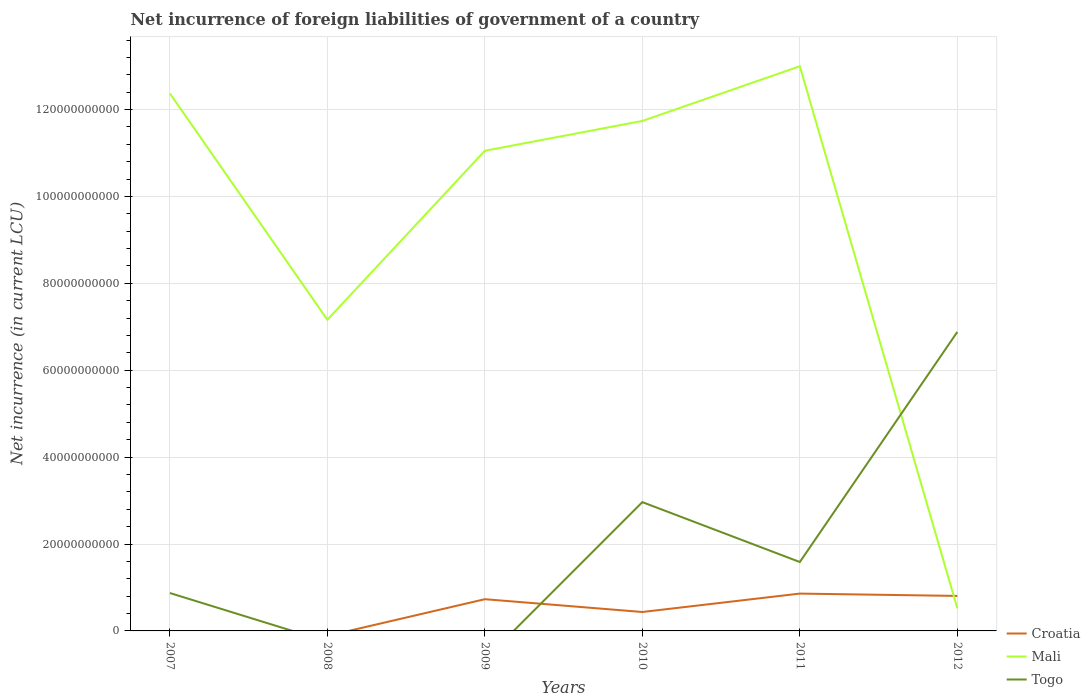Is the number of lines equal to the number of legend labels?
Give a very brief answer. No. Across all years, what is the maximum net incurrence of foreign liabilities in Mali?
Keep it short and to the point. 5.20e+09. What is the total net incurrence of foreign liabilities in Togo in the graph?
Offer a very short reply. -3.92e+1. What is the difference between the highest and the second highest net incurrence of foreign liabilities in Croatia?
Provide a short and direct response. 8.59e+09. Are the values on the major ticks of Y-axis written in scientific E-notation?
Ensure brevity in your answer.  No. Does the graph contain grids?
Your response must be concise. Yes. How are the legend labels stacked?
Provide a short and direct response. Vertical. What is the title of the graph?
Your response must be concise. Net incurrence of foreign liabilities of government of a country. What is the label or title of the X-axis?
Provide a short and direct response. Years. What is the label or title of the Y-axis?
Make the answer very short. Net incurrence (in current LCU). What is the Net incurrence (in current LCU) of Croatia in 2007?
Provide a short and direct response. 0. What is the Net incurrence (in current LCU) in Mali in 2007?
Make the answer very short. 1.24e+11. What is the Net incurrence (in current LCU) of Togo in 2007?
Keep it short and to the point. 8.72e+09. What is the Net incurrence (in current LCU) in Mali in 2008?
Your response must be concise. 7.16e+1. What is the Net incurrence (in current LCU) of Croatia in 2009?
Provide a short and direct response. 7.30e+09. What is the Net incurrence (in current LCU) in Mali in 2009?
Provide a succinct answer. 1.11e+11. What is the Net incurrence (in current LCU) of Croatia in 2010?
Give a very brief answer. 4.36e+09. What is the Net incurrence (in current LCU) of Mali in 2010?
Offer a very short reply. 1.17e+11. What is the Net incurrence (in current LCU) of Togo in 2010?
Keep it short and to the point. 2.96e+1. What is the Net incurrence (in current LCU) in Croatia in 2011?
Your answer should be compact. 8.59e+09. What is the Net incurrence (in current LCU) in Mali in 2011?
Keep it short and to the point. 1.30e+11. What is the Net incurrence (in current LCU) in Togo in 2011?
Keep it short and to the point. 1.59e+1. What is the Net incurrence (in current LCU) in Croatia in 2012?
Keep it short and to the point. 8.06e+09. What is the Net incurrence (in current LCU) of Mali in 2012?
Give a very brief answer. 5.20e+09. What is the Net incurrence (in current LCU) in Togo in 2012?
Ensure brevity in your answer.  6.88e+1. Across all years, what is the maximum Net incurrence (in current LCU) in Croatia?
Your response must be concise. 8.59e+09. Across all years, what is the maximum Net incurrence (in current LCU) of Mali?
Ensure brevity in your answer.  1.30e+11. Across all years, what is the maximum Net incurrence (in current LCU) of Togo?
Make the answer very short. 6.88e+1. Across all years, what is the minimum Net incurrence (in current LCU) of Mali?
Your answer should be compact. 5.20e+09. Across all years, what is the minimum Net incurrence (in current LCU) in Togo?
Give a very brief answer. 0. What is the total Net incurrence (in current LCU) in Croatia in the graph?
Your response must be concise. 2.83e+1. What is the total Net incurrence (in current LCU) in Mali in the graph?
Give a very brief answer. 5.58e+11. What is the total Net incurrence (in current LCU) of Togo in the graph?
Your answer should be compact. 1.23e+11. What is the difference between the Net incurrence (in current LCU) of Mali in 2007 and that in 2008?
Provide a succinct answer. 5.21e+1. What is the difference between the Net incurrence (in current LCU) of Mali in 2007 and that in 2009?
Offer a very short reply. 1.32e+1. What is the difference between the Net incurrence (in current LCU) in Mali in 2007 and that in 2010?
Keep it short and to the point. 6.32e+09. What is the difference between the Net incurrence (in current LCU) of Togo in 2007 and that in 2010?
Your answer should be compact. -2.09e+1. What is the difference between the Net incurrence (in current LCU) of Mali in 2007 and that in 2011?
Keep it short and to the point. -6.27e+09. What is the difference between the Net incurrence (in current LCU) of Togo in 2007 and that in 2011?
Your answer should be very brief. -7.14e+09. What is the difference between the Net incurrence (in current LCU) in Mali in 2007 and that in 2012?
Offer a terse response. 1.18e+11. What is the difference between the Net incurrence (in current LCU) in Togo in 2007 and that in 2012?
Your answer should be very brief. -6.01e+1. What is the difference between the Net incurrence (in current LCU) of Mali in 2008 and that in 2009?
Your answer should be compact. -3.89e+1. What is the difference between the Net incurrence (in current LCU) in Mali in 2008 and that in 2010?
Provide a succinct answer. -4.58e+1. What is the difference between the Net incurrence (in current LCU) in Mali in 2008 and that in 2011?
Offer a terse response. -5.84e+1. What is the difference between the Net incurrence (in current LCU) in Mali in 2008 and that in 2012?
Keep it short and to the point. 6.64e+1. What is the difference between the Net incurrence (in current LCU) of Croatia in 2009 and that in 2010?
Provide a short and direct response. 2.95e+09. What is the difference between the Net incurrence (in current LCU) of Mali in 2009 and that in 2010?
Your answer should be compact. -6.86e+09. What is the difference between the Net incurrence (in current LCU) of Croatia in 2009 and that in 2011?
Your answer should be compact. -1.29e+09. What is the difference between the Net incurrence (in current LCU) in Mali in 2009 and that in 2011?
Your response must be concise. -1.94e+1. What is the difference between the Net incurrence (in current LCU) of Croatia in 2009 and that in 2012?
Provide a short and direct response. -7.54e+08. What is the difference between the Net incurrence (in current LCU) in Mali in 2009 and that in 2012?
Offer a very short reply. 1.05e+11. What is the difference between the Net incurrence (in current LCU) in Croatia in 2010 and that in 2011?
Make the answer very short. -4.24e+09. What is the difference between the Net incurrence (in current LCU) of Mali in 2010 and that in 2011?
Make the answer very short. -1.26e+1. What is the difference between the Net incurrence (in current LCU) in Togo in 2010 and that in 2011?
Offer a terse response. 1.38e+1. What is the difference between the Net incurrence (in current LCU) of Croatia in 2010 and that in 2012?
Provide a short and direct response. -3.70e+09. What is the difference between the Net incurrence (in current LCU) of Mali in 2010 and that in 2012?
Keep it short and to the point. 1.12e+11. What is the difference between the Net incurrence (in current LCU) in Togo in 2010 and that in 2012?
Provide a succinct answer. -3.92e+1. What is the difference between the Net incurrence (in current LCU) in Croatia in 2011 and that in 2012?
Offer a terse response. 5.36e+08. What is the difference between the Net incurrence (in current LCU) of Mali in 2011 and that in 2012?
Your response must be concise. 1.25e+11. What is the difference between the Net incurrence (in current LCU) of Togo in 2011 and that in 2012?
Provide a short and direct response. -5.30e+1. What is the difference between the Net incurrence (in current LCU) in Mali in 2007 and the Net incurrence (in current LCU) in Togo in 2010?
Make the answer very short. 9.41e+1. What is the difference between the Net incurrence (in current LCU) in Mali in 2007 and the Net incurrence (in current LCU) in Togo in 2011?
Your response must be concise. 1.08e+11. What is the difference between the Net incurrence (in current LCU) of Mali in 2007 and the Net incurrence (in current LCU) of Togo in 2012?
Provide a short and direct response. 5.49e+1. What is the difference between the Net incurrence (in current LCU) of Mali in 2008 and the Net incurrence (in current LCU) of Togo in 2010?
Provide a short and direct response. 4.20e+1. What is the difference between the Net incurrence (in current LCU) of Mali in 2008 and the Net incurrence (in current LCU) of Togo in 2011?
Your answer should be very brief. 5.58e+1. What is the difference between the Net incurrence (in current LCU) in Mali in 2008 and the Net incurrence (in current LCU) in Togo in 2012?
Your response must be concise. 2.80e+09. What is the difference between the Net incurrence (in current LCU) of Croatia in 2009 and the Net incurrence (in current LCU) of Mali in 2010?
Your answer should be very brief. -1.10e+11. What is the difference between the Net incurrence (in current LCU) of Croatia in 2009 and the Net incurrence (in current LCU) of Togo in 2010?
Your response must be concise. -2.23e+1. What is the difference between the Net incurrence (in current LCU) of Mali in 2009 and the Net incurrence (in current LCU) of Togo in 2010?
Your answer should be compact. 8.09e+1. What is the difference between the Net incurrence (in current LCU) of Croatia in 2009 and the Net incurrence (in current LCU) of Mali in 2011?
Offer a very short reply. -1.23e+11. What is the difference between the Net incurrence (in current LCU) in Croatia in 2009 and the Net incurrence (in current LCU) in Togo in 2011?
Offer a very short reply. -8.56e+09. What is the difference between the Net incurrence (in current LCU) of Mali in 2009 and the Net incurrence (in current LCU) of Togo in 2011?
Your response must be concise. 9.47e+1. What is the difference between the Net incurrence (in current LCU) in Croatia in 2009 and the Net incurrence (in current LCU) in Mali in 2012?
Provide a succinct answer. 2.10e+09. What is the difference between the Net incurrence (in current LCU) in Croatia in 2009 and the Net incurrence (in current LCU) in Togo in 2012?
Ensure brevity in your answer.  -6.15e+1. What is the difference between the Net incurrence (in current LCU) in Mali in 2009 and the Net incurrence (in current LCU) in Togo in 2012?
Your response must be concise. 4.17e+1. What is the difference between the Net incurrence (in current LCU) in Croatia in 2010 and the Net incurrence (in current LCU) in Mali in 2011?
Offer a terse response. -1.26e+11. What is the difference between the Net incurrence (in current LCU) in Croatia in 2010 and the Net incurrence (in current LCU) in Togo in 2011?
Make the answer very short. -1.15e+1. What is the difference between the Net incurrence (in current LCU) of Mali in 2010 and the Net incurrence (in current LCU) of Togo in 2011?
Keep it short and to the point. 1.02e+11. What is the difference between the Net incurrence (in current LCU) of Croatia in 2010 and the Net incurrence (in current LCU) of Mali in 2012?
Your response must be concise. -8.47e+08. What is the difference between the Net incurrence (in current LCU) in Croatia in 2010 and the Net incurrence (in current LCU) in Togo in 2012?
Provide a short and direct response. -6.45e+1. What is the difference between the Net incurrence (in current LCU) of Mali in 2010 and the Net incurrence (in current LCU) of Togo in 2012?
Make the answer very short. 4.86e+1. What is the difference between the Net incurrence (in current LCU) in Croatia in 2011 and the Net incurrence (in current LCU) in Mali in 2012?
Provide a succinct answer. 3.39e+09. What is the difference between the Net incurrence (in current LCU) in Croatia in 2011 and the Net incurrence (in current LCU) in Togo in 2012?
Provide a succinct answer. -6.02e+1. What is the difference between the Net incurrence (in current LCU) in Mali in 2011 and the Net incurrence (in current LCU) in Togo in 2012?
Provide a succinct answer. 6.11e+1. What is the average Net incurrence (in current LCU) in Croatia per year?
Make the answer very short. 4.72e+09. What is the average Net incurrence (in current LCU) in Mali per year?
Give a very brief answer. 9.31e+1. What is the average Net incurrence (in current LCU) of Togo per year?
Provide a short and direct response. 2.05e+1. In the year 2007, what is the difference between the Net incurrence (in current LCU) of Mali and Net incurrence (in current LCU) of Togo?
Your answer should be compact. 1.15e+11. In the year 2009, what is the difference between the Net incurrence (in current LCU) in Croatia and Net incurrence (in current LCU) in Mali?
Keep it short and to the point. -1.03e+11. In the year 2010, what is the difference between the Net incurrence (in current LCU) in Croatia and Net incurrence (in current LCU) in Mali?
Your response must be concise. -1.13e+11. In the year 2010, what is the difference between the Net incurrence (in current LCU) in Croatia and Net incurrence (in current LCU) in Togo?
Your answer should be compact. -2.53e+1. In the year 2010, what is the difference between the Net incurrence (in current LCU) in Mali and Net incurrence (in current LCU) in Togo?
Keep it short and to the point. 8.77e+1. In the year 2011, what is the difference between the Net incurrence (in current LCU) of Croatia and Net incurrence (in current LCU) of Mali?
Offer a terse response. -1.21e+11. In the year 2011, what is the difference between the Net incurrence (in current LCU) of Croatia and Net incurrence (in current LCU) of Togo?
Offer a terse response. -7.27e+09. In the year 2011, what is the difference between the Net incurrence (in current LCU) in Mali and Net incurrence (in current LCU) in Togo?
Give a very brief answer. 1.14e+11. In the year 2012, what is the difference between the Net incurrence (in current LCU) in Croatia and Net incurrence (in current LCU) in Mali?
Offer a very short reply. 2.85e+09. In the year 2012, what is the difference between the Net incurrence (in current LCU) in Croatia and Net incurrence (in current LCU) in Togo?
Your answer should be compact. -6.08e+1. In the year 2012, what is the difference between the Net incurrence (in current LCU) of Mali and Net incurrence (in current LCU) of Togo?
Your answer should be compact. -6.36e+1. What is the ratio of the Net incurrence (in current LCU) of Mali in 2007 to that in 2008?
Offer a very short reply. 1.73. What is the ratio of the Net incurrence (in current LCU) of Mali in 2007 to that in 2009?
Your response must be concise. 1.12. What is the ratio of the Net incurrence (in current LCU) of Mali in 2007 to that in 2010?
Offer a terse response. 1.05. What is the ratio of the Net incurrence (in current LCU) in Togo in 2007 to that in 2010?
Keep it short and to the point. 0.29. What is the ratio of the Net incurrence (in current LCU) in Mali in 2007 to that in 2011?
Offer a terse response. 0.95. What is the ratio of the Net incurrence (in current LCU) of Togo in 2007 to that in 2011?
Keep it short and to the point. 0.55. What is the ratio of the Net incurrence (in current LCU) in Mali in 2007 to that in 2012?
Ensure brevity in your answer.  23.77. What is the ratio of the Net incurrence (in current LCU) in Togo in 2007 to that in 2012?
Provide a succinct answer. 0.13. What is the ratio of the Net incurrence (in current LCU) of Mali in 2008 to that in 2009?
Offer a terse response. 0.65. What is the ratio of the Net incurrence (in current LCU) of Mali in 2008 to that in 2010?
Provide a succinct answer. 0.61. What is the ratio of the Net incurrence (in current LCU) in Mali in 2008 to that in 2011?
Your response must be concise. 0.55. What is the ratio of the Net incurrence (in current LCU) in Mali in 2008 to that in 2012?
Offer a very short reply. 13.76. What is the ratio of the Net incurrence (in current LCU) of Croatia in 2009 to that in 2010?
Provide a short and direct response. 1.68. What is the ratio of the Net incurrence (in current LCU) in Mali in 2009 to that in 2010?
Offer a very short reply. 0.94. What is the ratio of the Net incurrence (in current LCU) in Croatia in 2009 to that in 2011?
Keep it short and to the point. 0.85. What is the ratio of the Net incurrence (in current LCU) of Mali in 2009 to that in 2011?
Make the answer very short. 0.85. What is the ratio of the Net incurrence (in current LCU) of Croatia in 2009 to that in 2012?
Provide a short and direct response. 0.91. What is the ratio of the Net incurrence (in current LCU) in Mali in 2009 to that in 2012?
Provide a succinct answer. 21.24. What is the ratio of the Net incurrence (in current LCU) of Croatia in 2010 to that in 2011?
Keep it short and to the point. 0.51. What is the ratio of the Net incurrence (in current LCU) of Mali in 2010 to that in 2011?
Give a very brief answer. 0.9. What is the ratio of the Net incurrence (in current LCU) in Togo in 2010 to that in 2011?
Your answer should be compact. 1.87. What is the ratio of the Net incurrence (in current LCU) of Croatia in 2010 to that in 2012?
Your response must be concise. 0.54. What is the ratio of the Net incurrence (in current LCU) of Mali in 2010 to that in 2012?
Offer a terse response. 22.56. What is the ratio of the Net incurrence (in current LCU) of Togo in 2010 to that in 2012?
Make the answer very short. 0.43. What is the ratio of the Net incurrence (in current LCU) of Croatia in 2011 to that in 2012?
Offer a terse response. 1.07. What is the ratio of the Net incurrence (in current LCU) of Mali in 2011 to that in 2012?
Keep it short and to the point. 24.98. What is the ratio of the Net incurrence (in current LCU) in Togo in 2011 to that in 2012?
Provide a short and direct response. 0.23. What is the difference between the highest and the second highest Net incurrence (in current LCU) of Croatia?
Give a very brief answer. 5.36e+08. What is the difference between the highest and the second highest Net incurrence (in current LCU) of Mali?
Provide a succinct answer. 6.27e+09. What is the difference between the highest and the second highest Net incurrence (in current LCU) of Togo?
Your response must be concise. 3.92e+1. What is the difference between the highest and the lowest Net incurrence (in current LCU) in Croatia?
Your response must be concise. 8.59e+09. What is the difference between the highest and the lowest Net incurrence (in current LCU) of Mali?
Offer a very short reply. 1.25e+11. What is the difference between the highest and the lowest Net incurrence (in current LCU) in Togo?
Provide a short and direct response. 6.88e+1. 